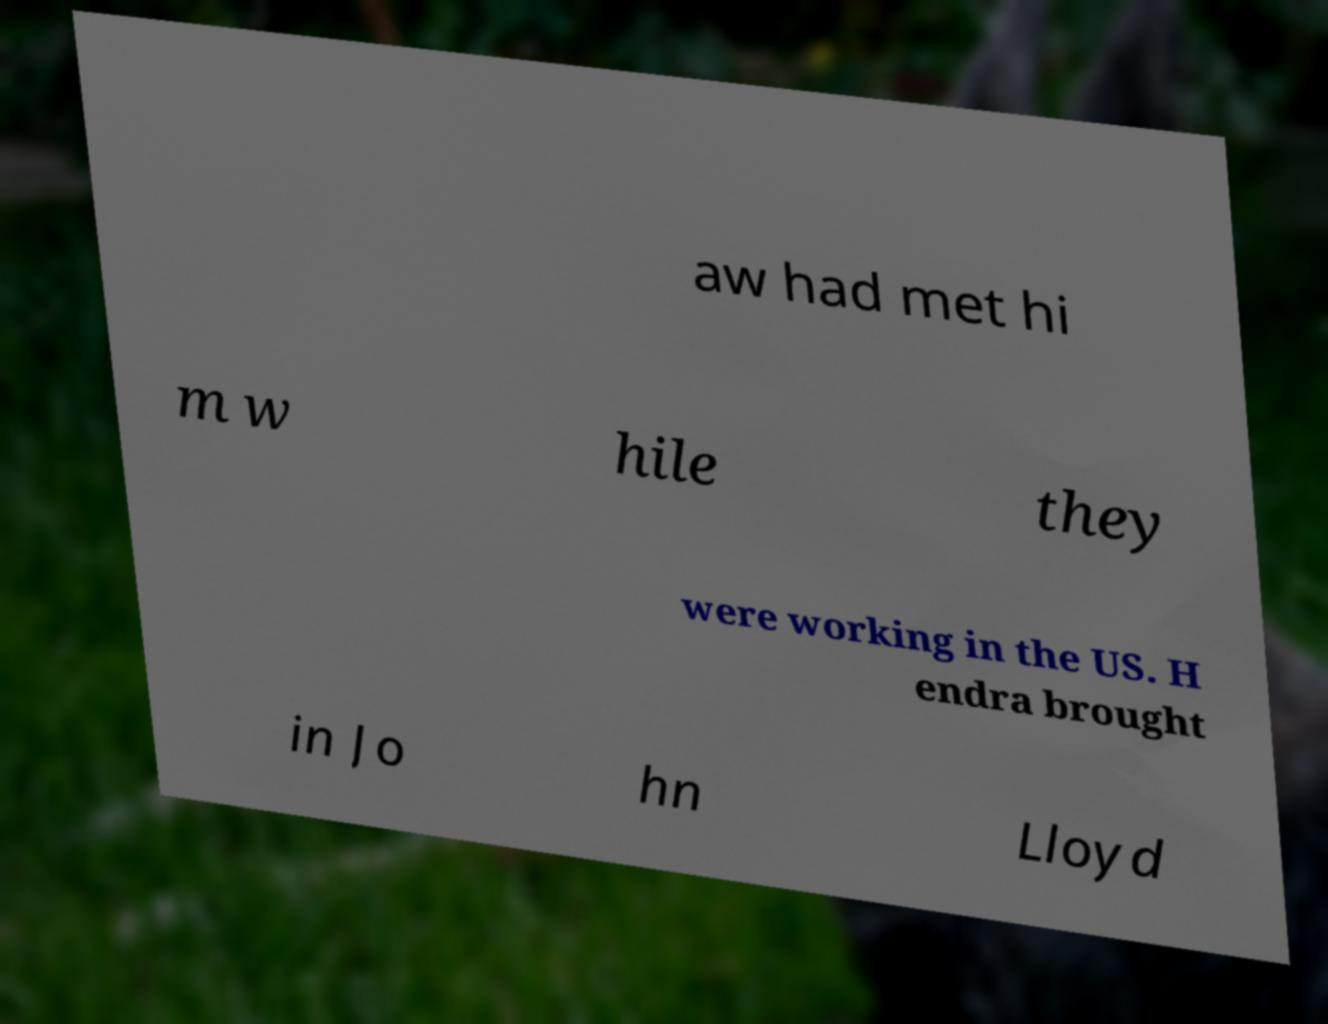Can you accurately transcribe the text from the provided image for me? aw had met hi m w hile they were working in the US. H endra brought in Jo hn Lloyd 